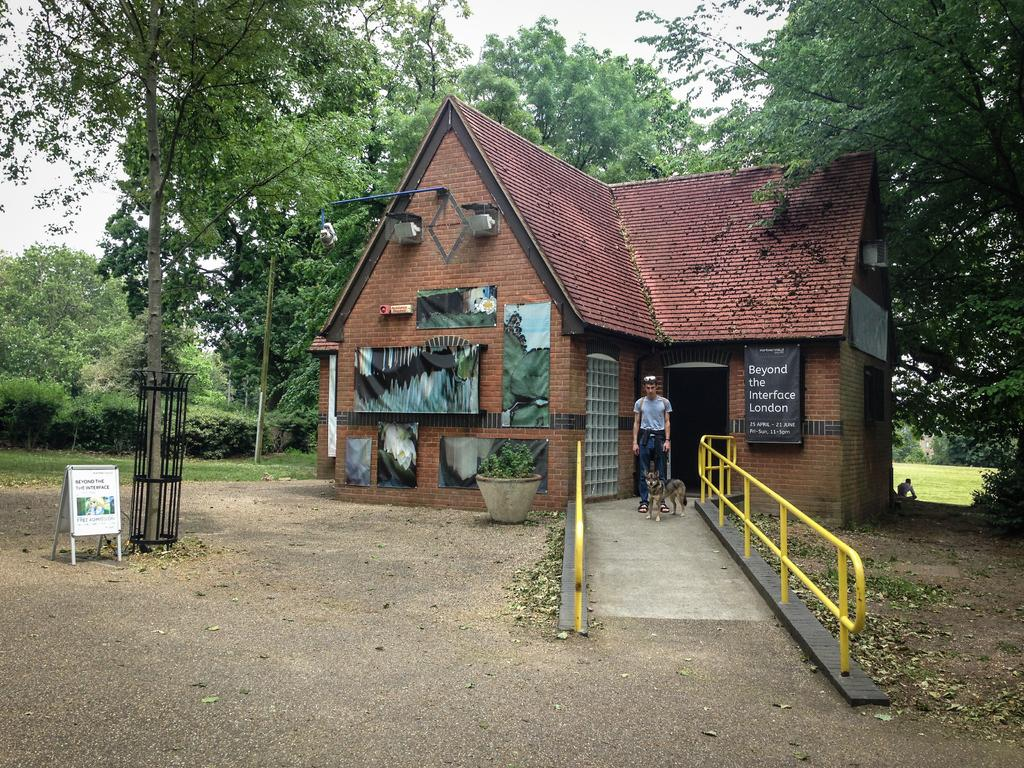<image>
Give a short and clear explanation of the subsequent image. a building with a poster hanging on the side of it that says 'beyond the interface london' 